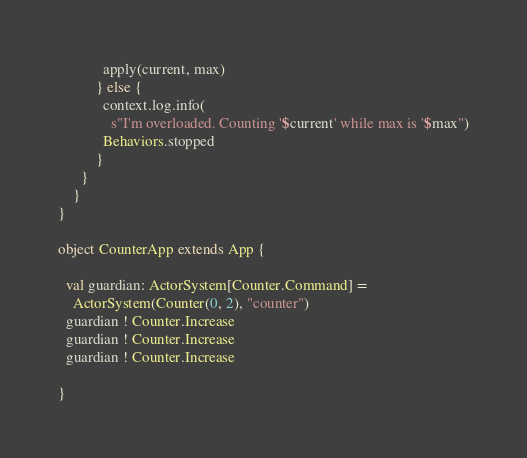Convert code to text. <code><loc_0><loc_0><loc_500><loc_500><_Scala_>            apply(current, max)
          } else {
            context.log.info(
              s"I'm overloaded. Counting '$current' while max is '$max")
            Behaviors.stopped
          }
      }
    }
}

object CounterApp extends App {

  val guardian: ActorSystem[Counter.Command] =
    ActorSystem(Counter(0, 2), "counter")
  guardian ! Counter.Increase
  guardian ! Counter.Increase
  guardian ! Counter.Increase

}
</code> 